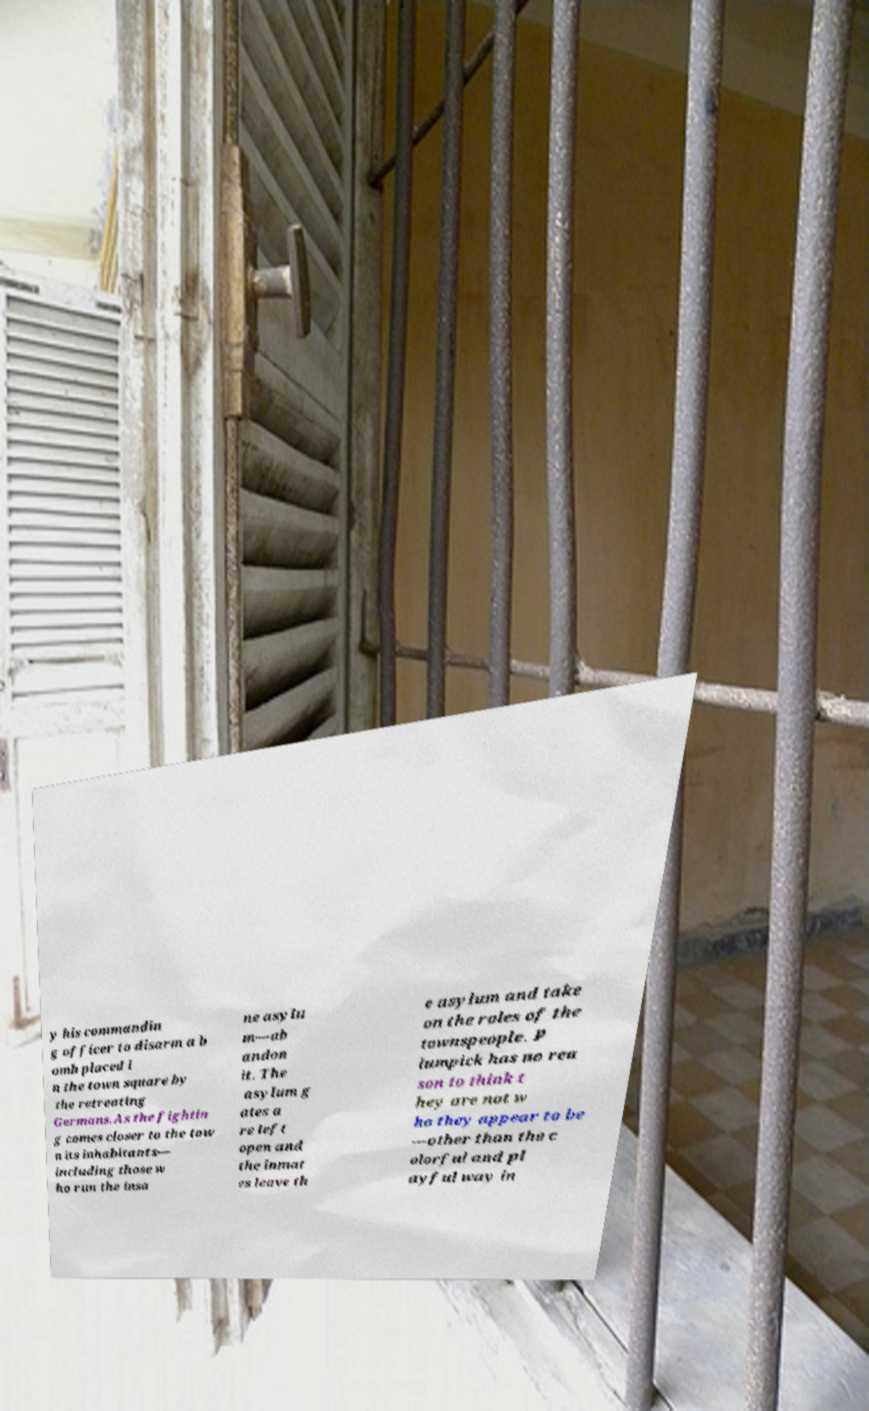There's text embedded in this image that I need extracted. Can you transcribe it verbatim? y his commandin g officer to disarm a b omb placed i n the town square by the retreating Germans.As the fightin g comes closer to the tow n its inhabitants— including those w ho run the insa ne asylu m—ab andon it. The asylum g ates a re left open and the inmat es leave th e asylum and take on the roles of the townspeople. P lumpick has no rea son to think t hey are not w ho they appear to be —other than the c olorful and pl ayful way in 